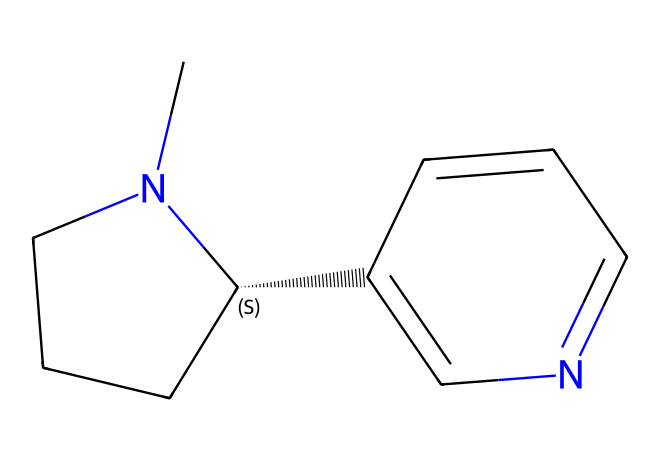What is the molecular formula of nicotine? To find the molecular formula, count the carbon (C), hydrogen (H), and nitrogen (N) atoms in the SMILES representation. There are 10 carbon atoms, 14 hydrogen atoms, and 2 nitrogen atoms. Thus, the molecular formula is C10H14N2.
Answer: C10H14N2 How many rings are present in nicotine? By analyzing the structure, we observe two distinct ring formations in the SMILES representation. One is a five-membered ring (the piperidine component), and the other is a six-membered ring (the pyridine part). Therefore, there are two rings.
Answer: 2 What functional groups are present in nicotine? The two primary functional groups in nicotine are the nitrogen-containing ring (pyridine) and the piperidine moiety. These structures contribute to its classification as an alkaloid due to the presence of nitrogen atoms.
Answer: alkaloid Is nicotine hydrophilic or hydrophobic? The presence of nitrogen atoms contributes to some degree of polarity, but several carbon chains are present as well, which are hydrophobic. In general, nicotine is slightly hydrophilic due to its ability to interact with water because of the nitrogen, but is predominantly hydrophobic.
Answer: slightly hydrophilic What is the primary toxic effect of nicotine? Nicotine primarily acts as a central nervous system stimulant and can lead to increased heart rate and blood pressure due to its action on nicotinic acetylcholine receptors. This is why it is classified as a neurotoxin.
Answer: neurotoxin 